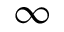Convert formula to latex. <formula><loc_0><loc_0><loc_500><loc_500>\infty</formula> 